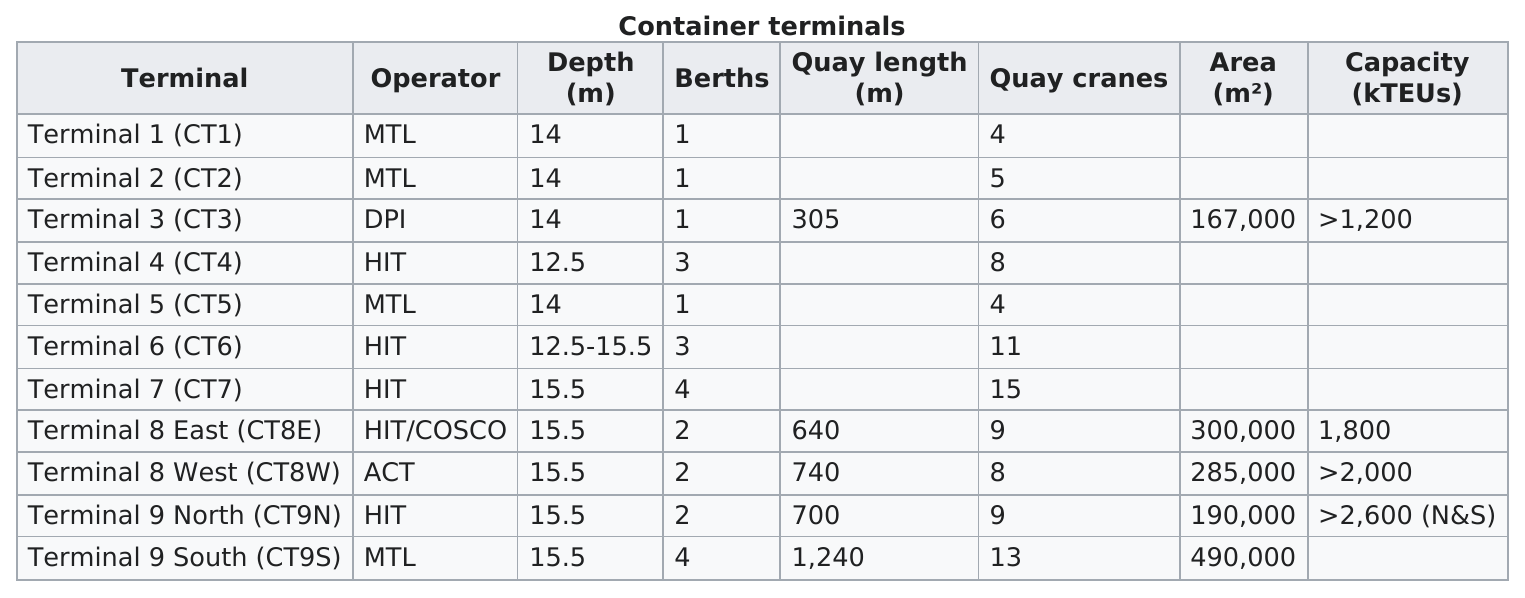Specify some key components in this picture. It is estimated that approximately 7 terminals had a minimum of 8 or more quay cranes. Terminal 7 (CT7) had more quay cranes than Terminal 6, and Terminal 9 South (CT9S) also had more quay cranes than Terminal 6. Terminal 9 South (CT9S) was longer than terminal 8 west. Terminal 2 (CT2), Terminal 3 (CT3), and Terminal 5 (CT5) all had the same depth as Terminal 1. The term 'hit' is listed as an operator five times in the range 5.. 